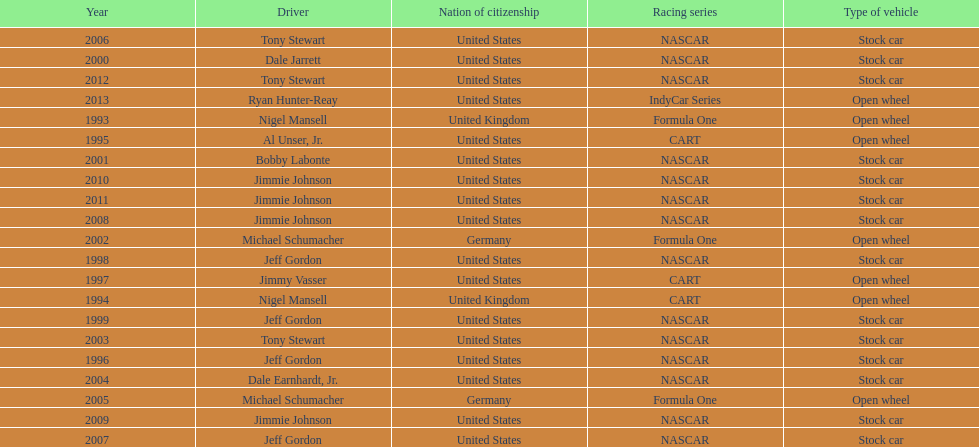How many times did jeff gordon win the award? 4. 